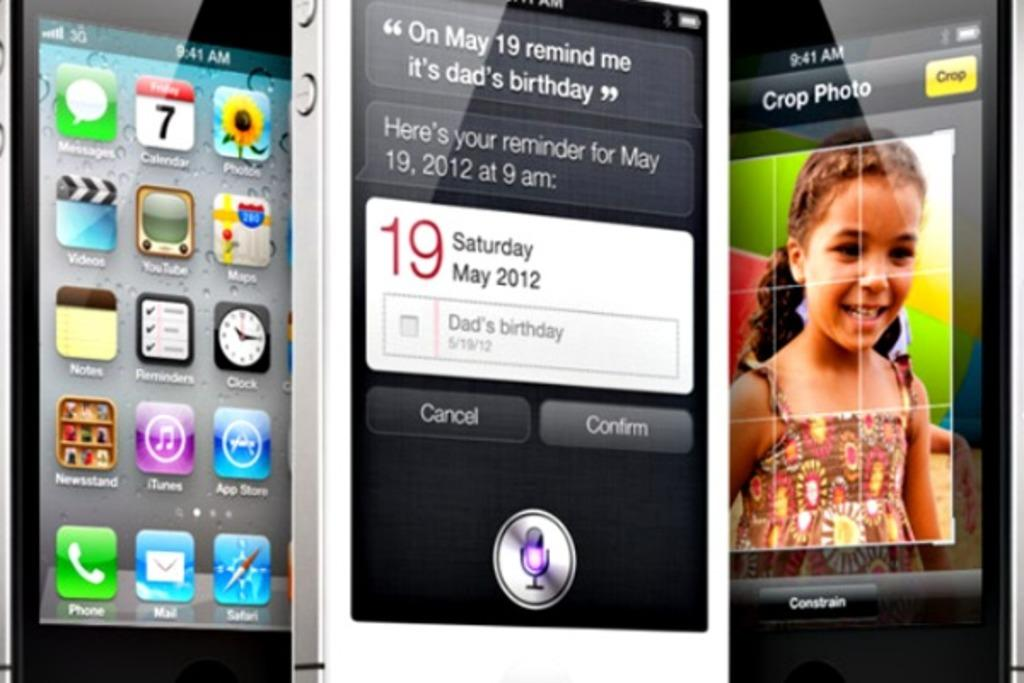<image>
Present a compact description of the photo's key features. Three phone screens are on display, one of which has a crop photo tool open. 